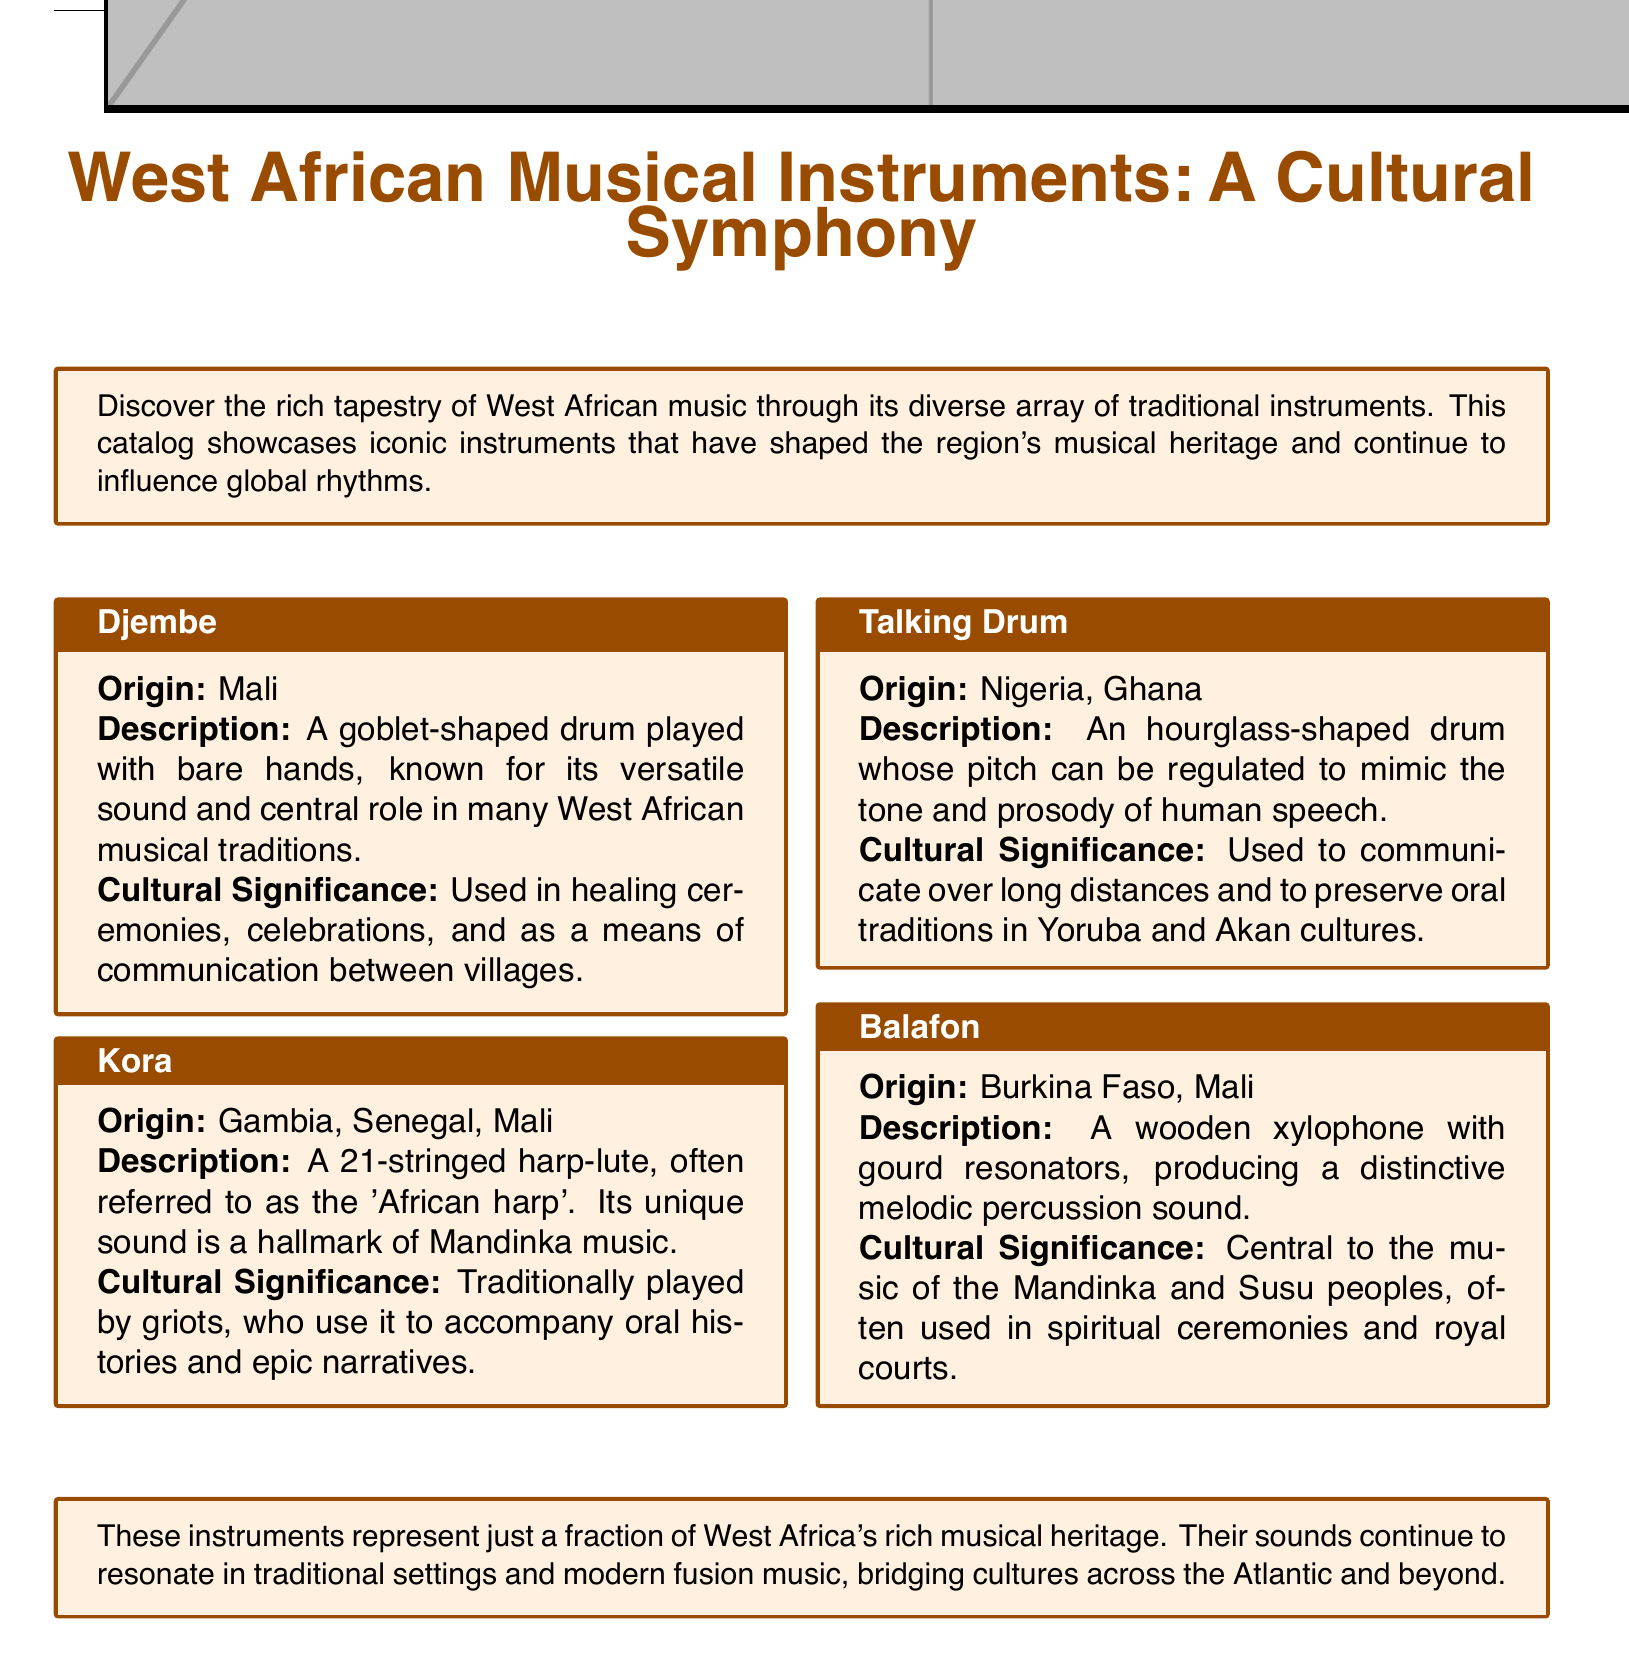What is the origin of the Djembe? The document states that the origin of the Djembe is Mali.
Answer: Mali How many strings does the Kora have? The Kora is described as a 21-stringed harp-lute in the document.
Answer: 21 What is the purpose of the Talking Drum? The document mentions that the Talking Drum is used to communicate over long distances.
Answer: Communicate Which instrument is used in spiritual ceremonies? The Balafon is referenced as being used in spiritual ceremonies in the text.
Answer: Balafon What role do griots have in relation to the Kora? The document explains that griots traditionally play the Kora to accompany oral histories.
Answer: Accompany oral histories How does the pitch of the Talking Drum get regulated? The document states that the pitch of the Talking Drum can be regulated to mimic human speech.
Answer: Mimic human speech What instruments are highlighted in the catalog as iconic? The document features the Djembe, Kora, Talking Drum, and Balafon as iconic instruments.
Answer: Djembe, Kora, Talking Drum, Balafon What type of document is this? This document is a catalog showcasing West African musical instruments.
Answer: Catalog 